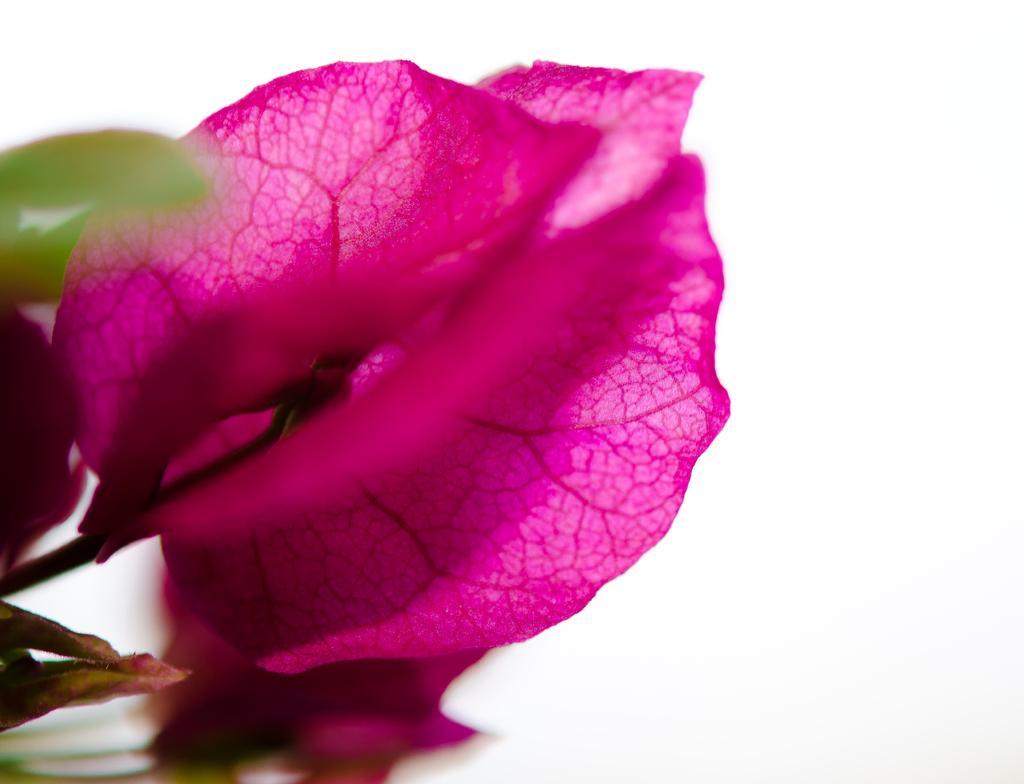Could you give a brief overview of what you see in this image? In this image, this looks like a flower, which is pink in color. I think this is a stem. The background looks white in color. 